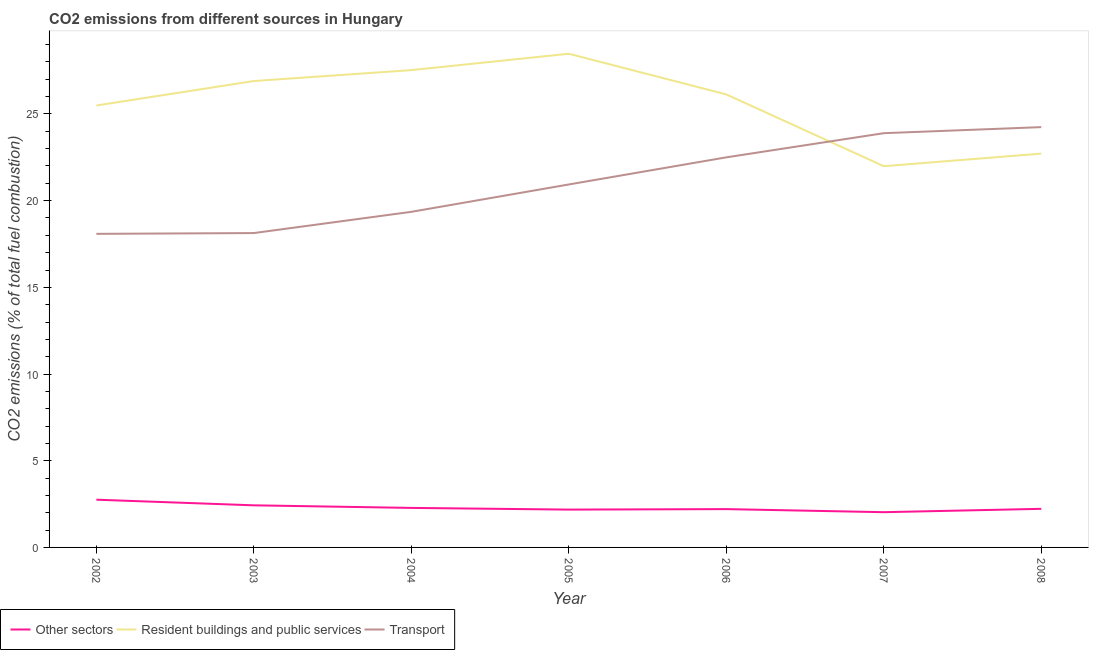What is the percentage of co2 emissions from transport in 2008?
Offer a very short reply. 24.24. Across all years, what is the maximum percentage of co2 emissions from resident buildings and public services?
Keep it short and to the point. 28.47. Across all years, what is the minimum percentage of co2 emissions from other sectors?
Your response must be concise. 2.03. In which year was the percentage of co2 emissions from transport maximum?
Your response must be concise. 2008. In which year was the percentage of co2 emissions from transport minimum?
Your response must be concise. 2002. What is the total percentage of co2 emissions from other sectors in the graph?
Give a very brief answer. 16.11. What is the difference between the percentage of co2 emissions from resident buildings and public services in 2003 and that in 2005?
Your answer should be compact. -1.57. What is the difference between the percentage of co2 emissions from other sectors in 2008 and the percentage of co2 emissions from transport in 2004?
Offer a terse response. -17.13. What is the average percentage of co2 emissions from transport per year?
Offer a terse response. 21.02. In the year 2007, what is the difference between the percentage of co2 emissions from other sectors and percentage of co2 emissions from resident buildings and public services?
Keep it short and to the point. -19.96. In how many years, is the percentage of co2 emissions from other sectors greater than 26 %?
Your answer should be compact. 0. What is the ratio of the percentage of co2 emissions from other sectors in 2002 to that in 2008?
Offer a very short reply. 1.24. What is the difference between the highest and the second highest percentage of co2 emissions from other sectors?
Ensure brevity in your answer.  0.33. What is the difference between the highest and the lowest percentage of co2 emissions from resident buildings and public services?
Ensure brevity in your answer.  6.48. In how many years, is the percentage of co2 emissions from other sectors greater than the average percentage of co2 emissions from other sectors taken over all years?
Your response must be concise. 2. Is the percentage of co2 emissions from resident buildings and public services strictly greater than the percentage of co2 emissions from other sectors over the years?
Keep it short and to the point. Yes. How many lines are there?
Give a very brief answer. 3. How many years are there in the graph?
Your answer should be very brief. 7. Does the graph contain any zero values?
Your answer should be compact. No. Does the graph contain grids?
Provide a succinct answer. No. How are the legend labels stacked?
Provide a succinct answer. Horizontal. What is the title of the graph?
Give a very brief answer. CO2 emissions from different sources in Hungary. What is the label or title of the X-axis?
Give a very brief answer. Year. What is the label or title of the Y-axis?
Offer a terse response. CO2 emissions (% of total fuel combustion). What is the CO2 emissions (% of total fuel combustion) of Other sectors in 2002?
Your response must be concise. 2.75. What is the CO2 emissions (% of total fuel combustion) in Resident buildings and public services in 2002?
Make the answer very short. 25.49. What is the CO2 emissions (% of total fuel combustion) in Transport in 2002?
Your answer should be very brief. 18.09. What is the CO2 emissions (% of total fuel combustion) of Other sectors in 2003?
Provide a succinct answer. 2.43. What is the CO2 emissions (% of total fuel combustion) in Resident buildings and public services in 2003?
Offer a very short reply. 26.9. What is the CO2 emissions (% of total fuel combustion) in Transport in 2003?
Offer a terse response. 18.13. What is the CO2 emissions (% of total fuel combustion) in Other sectors in 2004?
Ensure brevity in your answer.  2.28. What is the CO2 emissions (% of total fuel combustion) in Resident buildings and public services in 2004?
Keep it short and to the point. 27.53. What is the CO2 emissions (% of total fuel combustion) in Transport in 2004?
Your response must be concise. 19.36. What is the CO2 emissions (% of total fuel combustion) of Other sectors in 2005?
Provide a succinct answer. 2.18. What is the CO2 emissions (% of total fuel combustion) of Resident buildings and public services in 2005?
Your answer should be compact. 28.47. What is the CO2 emissions (% of total fuel combustion) of Transport in 2005?
Your answer should be very brief. 20.93. What is the CO2 emissions (% of total fuel combustion) of Other sectors in 2006?
Keep it short and to the point. 2.21. What is the CO2 emissions (% of total fuel combustion) in Resident buildings and public services in 2006?
Keep it short and to the point. 26.13. What is the CO2 emissions (% of total fuel combustion) of Transport in 2006?
Your answer should be very brief. 22.5. What is the CO2 emissions (% of total fuel combustion) in Other sectors in 2007?
Provide a succinct answer. 2.03. What is the CO2 emissions (% of total fuel combustion) of Resident buildings and public services in 2007?
Keep it short and to the point. 21.99. What is the CO2 emissions (% of total fuel combustion) of Transport in 2007?
Keep it short and to the point. 23.89. What is the CO2 emissions (% of total fuel combustion) in Other sectors in 2008?
Provide a succinct answer. 2.23. What is the CO2 emissions (% of total fuel combustion) in Resident buildings and public services in 2008?
Provide a short and direct response. 22.71. What is the CO2 emissions (% of total fuel combustion) of Transport in 2008?
Offer a terse response. 24.24. Across all years, what is the maximum CO2 emissions (% of total fuel combustion) of Other sectors?
Provide a succinct answer. 2.75. Across all years, what is the maximum CO2 emissions (% of total fuel combustion) in Resident buildings and public services?
Provide a short and direct response. 28.47. Across all years, what is the maximum CO2 emissions (% of total fuel combustion) of Transport?
Your answer should be very brief. 24.24. Across all years, what is the minimum CO2 emissions (% of total fuel combustion) of Other sectors?
Provide a succinct answer. 2.03. Across all years, what is the minimum CO2 emissions (% of total fuel combustion) of Resident buildings and public services?
Make the answer very short. 21.99. Across all years, what is the minimum CO2 emissions (% of total fuel combustion) of Transport?
Your response must be concise. 18.09. What is the total CO2 emissions (% of total fuel combustion) in Other sectors in the graph?
Offer a terse response. 16.11. What is the total CO2 emissions (% of total fuel combustion) in Resident buildings and public services in the graph?
Ensure brevity in your answer.  179.22. What is the total CO2 emissions (% of total fuel combustion) of Transport in the graph?
Ensure brevity in your answer.  147.13. What is the difference between the CO2 emissions (% of total fuel combustion) in Other sectors in 2002 and that in 2003?
Ensure brevity in your answer.  0.33. What is the difference between the CO2 emissions (% of total fuel combustion) of Resident buildings and public services in 2002 and that in 2003?
Your answer should be very brief. -1.41. What is the difference between the CO2 emissions (% of total fuel combustion) of Transport in 2002 and that in 2003?
Keep it short and to the point. -0.05. What is the difference between the CO2 emissions (% of total fuel combustion) in Other sectors in 2002 and that in 2004?
Your response must be concise. 0.47. What is the difference between the CO2 emissions (% of total fuel combustion) of Resident buildings and public services in 2002 and that in 2004?
Offer a very short reply. -2.04. What is the difference between the CO2 emissions (% of total fuel combustion) of Transport in 2002 and that in 2004?
Provide a succinct answer. -1.27. What is the difference between the CO2 emissions (% of total fuel combustion) in Other sectors in 2002 and that in 2005?
Your answer should be very brief. 0.57. What is the difference between the CO2 emissions (% of total fuel combustion) in Resident buildings and public services in 2002 and that in 2005?
Offer a terse response. -2.98. What is the difference between the CO2 emissions (% of total fuel combustion) in Transport in 2002 and that in 2005?
Give a very brief answer. -2.85. What is the difference between the CO2 emissions (% of total fuel combustion) of Other sectors in 2002 and that in 2006?
Provide a short and direct response. 0.54. What is the difference between the CO2 emissions (% of total fuel combustion) in Resident buildings and public services in 2002 and that in 2006?
Your response must be concise. -0.64. What is the difference between the CO2 emissions (% of total fuel combustion) of Transport in 2002 and that in 2006?
Give a very brief answer. -4.41. What is the difference between the CO2 emissions (% of total fuel combustion) in Other sectors in 2002 and that in 2007?
Your response must be concise. 0.72. What is the difference between the CO2 emissions (% of total fuel combustion) of Resident buildings and public services in 2002 and that in 2007?
Ensure brevity in your answer.  3.5. What is the difference between the CO2 emissions (% of total fuel combustion) of Transport in 2002 and that in 2007?
Your answer should be very brief. -5.81. What is the difference between the CO2 emissions (% of total fuel combustion) of Other sectors in 2002 and that in 2008?
Your response must be concise. 0.53. What is the difference between the CO2 emissions (% of total fuel combustion) in Resident buildings and public services in 2002 and that in 2008?
Provide a short and direct response. 2.77. What is the difference between the CO2 emissions (% of total fuel combustion) in Transport in 2002 and that in 2008?
Make the answer very short. -6.16. What is the difference between the CO2 emissions (% of total fuel combustion) in Other sectors in 2003 and that in 2004?
Provide a short and direct response. 0.15. What is the difference between the CO2 emissions (% of total fuel combustion) in Resident buildings and public services in 2003 and that in 2004?
Keep it short and to the point. -0.63. What is the difference between the CO2 emissions (% of total fuel combustion) in Transport in 2003 and that in 2004?
Your response must be concise. -1.22. What is the difference between the CO2 emissions (% of total fuel combustion) of Other sectors in 2003 and that in 2005?
Provide a succinct answer. 0.25. What is the difference between the CO2 emissions (% of total fuel combustion) of Resident buildings and public services in 2003 and that in 2005?
Offer a very short reply. -1.57. What is the difference between the CO2 emissions (% of total fuel combustion) in Transport in 2003 and that in 2005?
Ensure brevity in your answer.  -2.8. What is the difference between the CO2 emissions (% of total fuel combustion) of Other sectors in 2003 and that in 2006?
Keep it short and to the point. 0.22. What is the difference between the CO2 emissions (% of total fuel combustion) in Resident buildings and public services in 2003 and that in 2006?
Your answer should be compact. 0.77. What is the difference between the CO2 emissions (% of total fuel combustion) of Transport in 2003 and that in 2006?
Your response must be concise. -4.37. What is the difference between the CO2 emissions (% of total fuel combustion) in Other sectors in 2003 and that in 2007?
Give a very brief answer. 0.4. What is the difference between the CO2 emissions (% of total fuel combustion) in Resident buildings and public services in 2003 and that in 2007?
Offer a very short reply. 4.91. What is the difference between the CO2 emissions (% of total fuel combustion) of Transport in 2003 and that in 2007?
Your answer should be compact. -5.76. What is the difference between the CO2 emissions (% of total fuel combustion) in Other sectors in 2003 and that in 2008?
Your answer should be compact. 0.2. What is the difference between the CO2 emissions (% of total fuel combustion) in Resident buildings and public services in 2003 and that in 2008?
Offer a terse response. 4.19. What is the difference between the CO2 emissions (% of total fuel combustion) of Transport in 2003 and that in 2008?
Your response must be concise. -6.11. What is the difference between the CO2 emissions (% of total fuel combustion) in Other sectors in 2004 and that in 2005?
Offer a terse response. 0.1. What is the difference between the CO2 emissions (% of total fuel combustion) in Resident buildings and public services in 2004 and that in 2005?
Provide a short and direct response. -0.94. What is the difference between the CO2 emissions (% of total fuel combustion) in Transport in 2004 and that in 2005?
Offer a terse response. -1.58. What is the difference between the CO2 emissions (% of total fuel combustion) of Other sectors in 2004 and that in 2006?
Keep it short and to the point. 0.07. What is the difference between the CO2 emissions (% of total fuel combustion) in Resident buildings and public services in 2004 and that in 2006?
Your response must be concise. 1.4. What is the difference between the CO2 emissions (% of total fuel combustion) in Transport in 2004 and that in 2006?
Provide a succinct answer. -3.14. What is the difference between the CO2 emissions (% of total fuel combustion) in Other sectors in 2004 and that in 2007?
Give a very brief answer. 0.25. What is the difference between the CO2 emissions (% of total fuel combustion) of Resident buildings and public services in 2004 and that in 2007?
Provide a succinct answer. 5.54. What is the difference between the CO2 emissions (% of total fuel combustion) of Transport in 2004 and that in 2007?
Keep it short and to the point. -4.54. What is the difference between the CO2 emissions (% of total fuel combustion) of Other sectors in 2004 and that in 2008?
Keep it short and to the point. 0.05. What is the difference between the CO2 emissions (% of total fuel combustion) of Resident buildings and public services in 2004 and that in 2008?
Ensure brevity in your answer.  4.82. What is the difference between the CO2 emissions (% of total fuel combustion) in Transport in 2004 and that in 2008?
Offer a terse response. -4.89. What is the difference between the CO2 emissions (% of total fuel combustion) in Other sectors in 2005 and that in 2006?
Make the answer very short. -0.03. What is the difference between the CO2 emissions (% of total fuel combustion) in Resident buildings and public services in 2005 and that in 2006?
Offer a very short reply. 2.35. What is the difference between the CO2 emissions (% of total fuel combustion) of Transport in 2005 and that in 2006?
Provide a short and direct response. -1.56. What is the difference between the CO2 emissions (% of total fuel combustion) of Other sectors in 2005 and that in 2007?
Offer a very short reply. 0.15. What is the difference between the CO2 emissions (% of total fuel combustion) in Resident buildings and public services in 2005 and that in 2007?
Offer a terse response. 6.48. What is the difference between the CO2 emissions (% of total fuel combustion) of Transport in 2005 and that in 2007?
Your answer should be very brief. -2.96. What is the difference between the CO2 emissions (% of total fuel combustion) of Other sectors in 2005 and that in 2008?
Ensure brevity in your answer.  -0.04. What is the difference between the CO2 emissions (% of total fuel combustion) of Resident buildings and public services in 2005 and that in 2008?
Offer a terse response. 5.76. What is the difference between the CO2 emissions (% of total fuel combustion) in Transport in 2005 and that in 2008?
Provide a short and direct response. -3.31. What is the difference between the CO2 emissions (% of total fuel combustion) in Other sectors in 2006 and that in 2007?
Offer a very short reply. 0.18. What is the difference between the CO2 emissions (% of total fuel combustion) of Resident buildings and public services in 2006 and that in 2007?
Make the answer very short. 4.14. What is the difference between the CO2 emissions (% of total fuel combustion) of Transport in 2006 and that in 2007?
Your response must be concise. -1.39. What is the difference between the CO2 emissions (% of total fuel combustion) of Other sectors in 2006 and that in 2008?
Offer a terse response. -0.02. What is the difference between the CO2 emissions (% of total fuel combustion) of Resident buildings and public services in 2006 and that in 2008?
Ensure brevity in your answer.  3.41. What is the difference between the CO2 emissions (% of total fuel combustion) in Transport in 2006 and that in 2008?
Provide a short and direct response. -1.74. What is the difference between the CO2 emissions (% of total fuel combustion) of Other sectors in 2007 and that in 2008?
Provide a short and direct response. -0.19. What is the difference between the CO2 emissions (% of total fuel combustion) in Resident buildings and public services in 2007 and that in 2008?
Give a very brief answer. -0.72. What is the difference between the CO2 emissions (% of total fuel combustion) of Transport in 2007 and that in 2008?
Provide a short and direct response. -0.35. What is the difference between the CO2 emissions (% of total fuel combustion) of Other sectors in 2002 and the CO2 emissions (% of total fuel combustion) of Resident buildings and public services in 2003?
Your answer should be compact. -24.15. What is the difference between the CO2 emissions (% of total fuel combustion) of Other sectors in 2002 and the CO2 emissions (% of total fuel combustion) of Transport in 2003?
Offer a very short reply. -15.38. What is the difference between the CO2 emissions (% of total fuel combustion) of Resident buildings and public services in 2002 and the CO2 emissions (% of total fuel combustion) of Transport in 2003?
Provide a short and direct response. 7.36. What is the difference between the CO2 emissions (% of total fuel combustion) of Other sectors in 2002 and the CO2 emissions (% of total fuel combustion) of Resident buildings and public services in 2004?
Offer a terse response. -24.78. What is the difference between the CO2 emissions (% of total fuel combustion) in Other sectors in 2002 and the CO2 emissions (% of total fuel combustion) in Transport in 2004?
Give a very brief answer. -16.6. What is the difference between the CO2 emissions (% of total fuel combustion) of Resident buildings and public services in 2002 and the CO2 emissions (% of total fuel combustion) of Transport in 2004?
Make the answer very short. 6.13. What is the difference between the CO2 emissions (% of total fuel combustion) in Other sectors in 2002 and the CO2 emissions (% of total fuel combustion) in Resident buildings and public services in 2005?
Your answer should be compact. -25.72. What is the difference between the CO2 emissions (% of total fuel combustion) of Other sectors in 2002 and the CO2 emissions (% of total fuel combustion) of Transport in 2005?
Make the answer very short. -18.18. What is the difference between the CO2 emissions (% of total fuel combustion) of Resident buildings and public services in 2002 and the CO2 emissions (% of total fuel combustion) of Transport in 2005?
Your answer should be compact. 4.55. What is the difference between the CO2 emissions (% of total fuel combustion) in Other sectors in 2002 and the CO2 emissions (% of total fuel combustion) in Resident buildings and public services in 2006?
Ensure brevity in your answer.  -23.37. What is the difference between the CO2 emissions (% of total fuel combustion) in Other sectors in 2002 and the CO2 emissions (% of total fuel combustion) in Transport in 2006?
Keep it short and to the point. -19.74. What is the difference between the CO2 emissions (% of total fuel combustion) in Resident buildings and public services in 2002 and the CO2 emissions (% of total fuel combustion) in Transport in 2006?
Give a very brief answer. 2.99. What is the difference between the CO2 emissions (% of total fuel combustion) of Other sectors in 2002 and the CO2 emissions (% of total fuel combustion) of Resident buildings and public services in 2007?
Your answer should be very brief. -19.24. What is the difference between the CO2 emissions (% of total fuel combustion) in Other sectors in 2002 and the CO2 emissions (% of total fuel combustion) in Transport in 2007?
Make the answer very short. -21.14. What is the difference between the CO2 emissions (% of total fuel combustion) of Resident buildings and public services in 2002 and the CO2 emissions (% of total fuel combustion) of Transport in 2007?
Keep it short and to the point. 1.6. What is the difference between the CO2 emissions (% of total fuel combustion) in Other sectors in 2002 and the CO2 emissions (% of total fuel combustion) in Resident buildings and public services in 2008?
Keep it short and to the point. -19.96. What is the difference between the CO2 emissions (% of total fuel combustion) of Other sectors in 2002 and the CO2 emissions (% of total fuel combustion) of Transport in 2008?
Your answer should be compact. -21.49. What is the difference between the CO2 emissions (% of total fuel combustion) in Resident buildings and public services in 2002 and the CO2 emissions (% of total fuel combustion) in Transport in 2008?
Your answer should be very brief. 1.25. What is the difference between the CO2 emissions (% of total fuel combustion) in Other sectors in 2003 and the CO2 emissions (% of total fuel combustion) in Resident buildings and public services in 2004?
Ensure brevity in your answer.  -25.1. What is the difference between the CO2 emissions (% of total fuel combustion) of Other sectors in 2003 and the CO2 emissions (% of total fuel combustion) of Transport in 2004?
Give a very brief answer. -16.93. What is the difference between the CO2 emissions (% of total fuel combustion) in Resident buildings and public services in 2003 and the CO2 emissions (% of total fuel combustion) in Transport in 2004?
Give a very brief answer. 7.54. What is the difference between the CO2 emissions (% of total fuel combustion) of Other sectors in 2003 and the CO2 emissions (% of total fuel combustion) of Resident buildings and public services in 2005?
Ensure brevity in your answer.  -26.04. What is the difference between the CO2 emissions (% of total fuel combustion) of Other sectors in 2003 and the CO2 emissions (% of total fuel combustion) of Transport in 2005?
Keep it short and to the point. -18.51. What is the difference between the CO2 emissions (% of total fuel combustion) of Resident buildings and public services in 2003 and the CO2 emissions (% of total fuel combustion) of Transport in 2005?
Provide a succinct answer. 5.97. What is the difference between the CO2 emissions (% of total fuel combustion) in Other sectors in 2003 and the CO2 emissions (% of total fuel combustion) in Resident buildings and public services in 2006?
Your answer should be very brief. -23.7. What is the difference between the CO2 emissions (% of total fuel combustion) in Other sectors in 2003 and the CO2 emissions (% of total fuel combustion) in Transport in 2006?
Provide a succinct answer. -20.07. What is the difference between the CO2 emissions (% of total fuel combustion) of Resident buildings and public services in 2003 and the CO2 emissions (% of total fuel combustion) of Transport in 2006?
Make the answer very short. 4.4. What is the difference between the CO2 emissions (% of total fuel combustion) in Other sectors in 2003 and the CO2 emissions (% of total fuel combustion) in Resident buildings and public services in 2007?
Provide a short and direct response. -19.56. What is the difference between the CO2 emissions (% of total fuel combustion) in Other sectors in 2003 and the CO2 emissions (% of total fuel combustion) in Transport in 2007?
Provide a succinct answer. -21.46. What is the difference between the CO2 emissions (% of total fuel combustion) in Resident buildings and public services in 2003 and the CO2 emissions (% of total fuel combustion) in Transport in 2007?
Offer a terse response. 3.01. What is the difference between the CO2 emissions (% of total fuel combustion) of Other sectors in 2003 and the CO2 emissions (% of total fuel combustion) of Resident buildings and public services in 2008?
Make the answer very short. -20.28. What is the difference between the CO2 emissions (% of total fuel combustion) of Other sectors in 2003 and the CO2 emissions (% of total fuel combustion) of Transport in 2008?
Your answer should be compact. -21.81. What is the difference between the CO2 emissions (% of total fuel combustion) in Resident buildings and public services in 2003 and the CO2 emissions (% of total fuel combustion) in Transport in 2008?
Provide a short and direct response. 2.66. What is the difference between the CO2 emissions (% of total fuel combustion) of Other sectors in 2004 and the CO2 emissions (% of total fuel combustion) of Resident buildings and public services in 2005?
Give a very brief answer. -26.19. What is the difference between the CO2 emissions (% of total fuel combustion) in Other sectors in 2004 and the CO2 emissions (% of total fuel combustion) in Transport in 2005?
Your answer should be compact. -18.65. What is the difference between the CO2 emissions (% of total fuel combustion) in Resident buildings and public services in 2004 and the CO2 emissions (% of total fuel combustion) in Transport in 2005?
Ensure brevity in your answer.  6.6. What is the difference between the CO2 emissions (% of total fuel combustion) of Other sectors in 2004 and the CO2 emissions (% of total fuel combustion) of Resident buildings and public services in 2006?
Make the answer very short. -23.85. What is the difference between the CO2 emissions (% of total fuel combustion) in Other sectors in 2004 and the CO2 emissions (% of total fuel combustion) in Transport in 2006?
Provide a succinct answer. -20.22. What is the difference between the CO2 emissions (% of total fuel combustion) of Resident buildings and public services in 2004 and the CO2 emissions (% of total fuel combustion) of Transport in 2006?
Your answer should be compact. 5.03. What is the difference between the CO2 emissions (% of total fuel combustion) of Other sectors in 2004 and the CO2 emissions (% of total fuel combustion) of Resident buildings and public services in 2007?
Offer a terse response. -19.71. What is the difference between the CO2 emissions (% of total fuel combustion) of Other sectors in 2004 and the CO2 emissions (% of total fuel combustion) of Transport in 2007?
Your response must be concise. -21.61. What is the difference between the CO2 emissions (% of total fuel combustion) in Resident buildings and public services in 2004 and the CO2 emissions (% of total fuel combustion) in Transport in 2007?
Your answer should be compact. 3.64. What is the difference between the CO2 emissions (% of total fuel combustion) of Other sectors in 2004 and the CO2 emissions (% of total fuel combustion) of Resident buildings and public services in 2008?
Your response must be concise. -20.43. What is the difference between the CO2 emissions (% of total fuel combustion) in Other sectors in 2004 and the CO2 emissions (% of total fuel combustion) in Transport in 2008?
Your response must be concise. -21.96. What is the difference between the CO2 emissions (% of total fuel combustion) in Resident buildings and public services in 2004 and the CO2 emissions (% of total fuel combustion) in Transport in 2008?
Provide a short and direct response. 3.29. What is the difference between the CO2 emissions (% of total fuel combustion) in Other sectors in 2005 and the CO2 emissions (% of total fuel combustion) in Resident buildings and public services in 2006?
Your response must be concise. -23.95. What is the difference between the CO2 emissions (% of total fuel combustion) in Other sectors in 2005 and the CO2 emissions (% of total fuel combustion) in Transport in 2006?
Offer a very short reply. -20.32. What is the difference between the CO2 emissions (% of total fuel combustion) in Resident buildings and public services in 2005 and the CO2 emissions (% of total fuel combustion) in Transport in 2006?
Offer a terse response. 5.97. What is the difference between the CO2 emissions (% of total fuel combustion) of Other sectors in 2005 and the CO2 emissions (% of total fuel combustion) of Resident buildings and public services in 2007?
Offer a terse response. -19.81. What is the difference between the CO2 emissions (% of total fuel combustion) of Other sectors in 2005 and the CO2 emissions (% of total fuel combustion) of Transport in 2007?
Ensure brevity in your answer.  -21.71. What is the difference between the CO2 emissions (% of total fuel combustion) in Resident buildings and public services in 2005 and the CO2 emissions (% of total fuel combustion) in Transport in 2007?
Offer a very short reply. 4.58. What is the difference between the CO2 emissions (% of total fuel combustion) of Other sectors in 2005 and the CO2 emissions (% of total fuel combustion) of Resident buildings and public services in 2008?
Your answer should be compact. -20.53. What is the difference between the CO2 emissions (% of total fuel combustion) in Other sectors in 2005 and the CO2 emissions (% of total fuel combustion) in Transport in 2008?
Offer a terse response. -22.06. What is the difference between the CO2 emissions (% of total fuel combustion) in Resident buildings and public services in 2005 and the CO2 emissions (% of total fuel combustion) in Transport in 2008?
Keep it short and to the point. 4.23. What is the difference between the CO2 emissions (% of total fuel combustion) in Other sectors in 2006 and the CO2 emissions (% of total fuel combustion) in Resident buildings and public services in 2007?
Your response must be concise. -19.78. What is the difference between the CO2 emissions (% of total fuel combustion) in Other sectors in 2006 and the CO2 emissions (% of total fuel combustion) in Transport in 2007?
Your response must be concise. -21.68. What is the difference between the CO2 emissions (% of total fuel combustion) in Resident buildings and public services in 2006 and the CO2 emissions (% of total fuel combustion) in Transport in 2007?
Ensure brevity in your answer.  2.24. What is the difference between the CO2 emissions (% of total fuel combustion) of Other sectors in 2006 and the CO2 emissions (% of total fuel combustion) of Resident buildings and public services in 2008?
Your answer should be compact. -20.5. What is the difference between the CO2 emissions (% of total fuel combustion) in Other sectors in 2006 and the CO2 emissions (% of total fuel combustion) in Transport in 2008?
Offer a terse response. -22.03. What is the difference between the CO2 emissions (% of total fuel combustion) of Resident buildings and public services in 2006 and the CO2 emissions (% of total fuel combustion) of Transport in 2008?
Your response must be concise. 1.89. What is the difference between the CO2 emissions (% of total fuel combustion) of Other sectors in 2007 and the CO2 emissions (% of total fuel combustion) of Resident buildings and public services in 2008?
Provide a succinct answer. -20.68. What is the difference between the CO2 emissions (% of total fuel combustion) in Other sectors in 2007 and the CO2 emissions (% of total fuel combustion) in Transport in 2008?
Offer a terse response. -22.21. What is the difference between the CO2 emissions (% of total fuel combustion) of Resident buildings and public services in 2007 and the CO2 emissions (% of total fuel combustion) of Transport in 2008?
Ensure brevity in your answer.  -2.25. What is the average CO2 emissions (% of total fuel combustion) of Other sectors per year?
Offer a very short reply. 2.3. What is the average CO2 emissions (% of total fuel combustion) in Resident buildings and public services per year?
Provide a short and direct response. 25.6. What is the average CO2 emissions (% of total fuel combustion) in Transport per year?
Make the answer very short. 21.02. In the year 2002, what is the difference between the CO2 emissions (% of total fuel combustion) in Other sectors and CO2 emissions (% of total fuel combustion) in Resident buildings and public services?
Provide a short and direct response. -22.73. In the year 2002, what is the difference between the CO2 emissions (% of total fuel combustion) of Other sectors and CO2 emissions (% of total fuel combustion) of Transport?
Offer a terse response. -15.33. In the year 2002, what is the difference between the CO2 emissions (% of total fuel combustion) of Resident buildings and public services and CO2 emissions (% of total fuel combustion) of Transport?
Give a very brief answer. 7.4. In the year 2003, what is the difference between the CO2 emissions (% of total fuel combustion) of Other sectors and CO2 emissions (% of total fuel combustion) of Resident buildings and public services?
Offer a terse response. -24.47. In the year 2003, what is the difference between the CO2 emissions (% of total fuel combustion) of Other sectors and CO2 emissions (% of total fuel combustion) of Transport?
Provide a succinct answer. -15.7. In the year 2003, what is the difference between the CO2 emissions (% of total fuel combustion) of Resident buildings and public services and CO2 emissions (% of total fuel combustion) of Transport?
Provide a short and direct response. 8.77. In the year 2004, what is the difference between the CO2 emissions (% of total fuel combustion) in Other sectors and CO2 emissions (% of total fuel combustion) in Resident buildings and public services?
Ensure brevity in your answer.  -25.25. In the year 2004, what is the difference between the CO2 emissions (% of total fuel combustion) of Other sectors and CO2 emissions (% of total fuel combustion) of Transport?
Your answer should be very brief. -17.08. In the year 2004, what is the difference between the CO2 emissions (% of total fuel combustion) in Resident buildings and public services and CO2 emissions (% of total fuel combustion) in Transport?
Offer a very short reply. 8.17. In the year 2005, what is the difference between the CO2 emissions (% of total fuel combustion) in Other sectors and CO2 emissions (% of total fuel combustion) in Resident buildings and public services?
Your response must be concise. -26.29. In the year 2005, what is the difference between the CO2 emissions (% of total fuel combustion) of Other sectors and CO2 emissions (% of total fuel combustion) of Transport?
Make the answer very short. -18.75. In the year 2005, what is the difference between the CO2 emissions (% of total fuel combustion) of Resident buildings and public services and CO2 emissions (% of total fuel combustion) of Transport?
Your response must be concise. 7.54. In the year 2006, what is the difference between the CO2 emissions (% of total fuel combustion) of Other sectors and CO2 emissions (% of total fuel combustion) of Resident buildings and public services?
Ensure brevity in your answer.  -23.92. In the year 2006, what is the difference between the CO2 emissions (% of total fuel combustion) in Other sectors and CO2 emissions (% of total fuel combustion) in Transport?
Offer a terse response. -20.29. In the year 2006, what is the difference between the CO2 emissions (% of total fuel combustion) in Resident buildings and public services and CO2 emissions (% of total fuel combustion) in Transport?
Offer a terse response. 3.63. In the year 2007, what is the difference between the CO2 emissions (% of total fuel combustion) in Other sectors and CO2 emissions (% of total fuel combustion) in Resident buildings and public services?
Provide a succinct answer. -19.96. In the year 2007, what is the difference between the CO2 emissions (% of total fuel combustion) in Other sectors and CO2 emissions (% of total fuel combustion) in Transport?
Your answer should be very brief. -21.86. In the year 2007, what is the difference between the CO2 emissions (% of total fuel combustion) of Resident buildings and public services and CO2 emissions (% of total fuel combustion) of Transport?
Your answer should be very brief. -1.9. In the year 2008, what is the difference between the CO2 emissions (% of total fuel combustion) of Other sectors and CO2 emissions (% of total fuel combustion) of Resident buildings and public services?
Offer a very short reply. -20.49. In the year 2008, what is the difference between the CO2 emissions (% of total fuel combustion) of Other sectors and CO2 emissions (% of total fuel combustion) of Transport?
Offer a very short reply. -22.01. In the year 2008, what is the difference between the CO2 emissions (% of total fuel combustion) in Resident buildings and public services and CO2 emissions (% of total fuel combustion) in Transport?
Provide a short and direct response. -1.53. What is the ratio of the CO2 emissions (% of total fuel combustion) in Other sectors in 2002 to that in 2003?
Keep it short and to the point. 1.13. What is the ratio of the CO2 emissions (% of total fuel combustion) in Resident buildings and public services in 2002 to that in 2003?
Your answer should be compact. 0.95. What is the ratio of the CO2 emissions (% of total fuel combustion) in Transport in 2002 to that in 2003?
Provide a succinct answer. 1. What is the ratio of the CO2 emissions (% of total fuel combustion) of Other sectors in 2002 to that in 2004?
Ensure brevity in your answer.  1.21. What is the ratio of the CO2 emissions (% of total fuel combustion) in Resident buildings and public services in 2002 to that in 2004?
Your answer should be compact. 0.93. What is the ratio of the CO2 emissions (% of total fuel combustion) in Transport in 2002 to that in 2004?
Keep it short and to the point. 0.93. What is the ratio of the CO2 emissions (% of total fuel combustion) of Other sectors in 2002 to that in 2005?
Provide a short and direct response. 1.26. What is the ratio of the CO2 emissions (% of total fuel combustion) in Resident buildings and public services in 2002 to that in 2005?
Keep it short and to the point. 0.9. What is the ratio of the CO2 emissions (% of total fuel combustion) of Transport in 2002 to that in 2005?
Give a very brief answer. 0.86. What is the ratio of the CO2 emissions (% of total fuel combustion) of Other sectors in 2002 to that in 2006?
Your answer should be very brief. 1.25. What is the ratio of the CO2 emissions (% of total fuel combustion) in Resident buildings and public services in 2002 to that in 2006?
Offer a terse response. 0.98. What is the ratio of the CO2 emissions (% of total fuel combustion) of Transport in 2002 to that in 2006?
Offer a terse response. 0.8. What is the ratio of the CO2 emissions (% of total fuel combustion) in Other sectors in 2002 to that in 2007?
Your response must be concise. 1.35. What is the ratio of the CO2 emissions (% of total fuel combustion) in Resident buildings and public services in 2002 to that in 2007?
Offer a very short reply. 1.16. What is the ratio of the CO2 emissions (% of total fuel combustion) of Transport in 2002 to that in 2007?
Offer a terse response. 0.76. What is the ratio of the CO2 emissions (% of total fuel combustion) of Other sectors in 2002 to that in 2008?
Offer a terse response. 1.24. What is the ratio of the CO2 emissions (% of total fuel combustion) of Resident buildings and public services in 2002 to that in 2008?
Keep it short and to the point. 1.12. What is the ratio of the CO2 emissions (% of total fuel combustion) of Transport in 2002 to that in 2008?
Your answer should be compact. 0.75. What is the ratio of the CO2 emissions (% of total fuel combustion) of Other sectors in 2003 to that in 2004?
Provide a short and direct response. 1.07. What is the ratio of the CO2 emissions (% of total fuel combustion) in Resident buildings and public services in 2003 to that in 2004?
Make the answer very short. 0.98. What is the ratio of the CO2 emissions (% of total fuel combustion) in Transport in 2003 to that in 2004?
Provide a succinct answer. 0.94. What is the ratio of the CO2 emissions (% of total fuel combustion) in Other sectors in 2003 to that in 2005?
Ensure brevity in your answer.  1.11. What is the ratio of the CO2 emissions (% of total fuel combustion) in Resident buildings and public services in 2003 to that in 2005?
Keep it short and to the point. 0.94. What is the ratio of the CO2 emissions (% of total fuel combustion) of Transport in 2003 to that in 2005?
Make the answer very short. 0.87. What is the ratio of the CO2 emissions (% of total fuel combustion) in Other sectors in 2003 to that in 2006?
Keep it short and to the point. 1.1. What is the ratio of the CO2 emissions (% of total fuel combustion) in Resident buildings and public services in 2003 to that in 2006?
Your answer should be very brief. 1.03. What is the ratio of the CO2 emissions (% of total fuel combustion) in Transport in 2003 to that in 2006?
Offer a very short reply. 0.81. What is the ratio of the CO2 emissions (% of total fuel combustion) of Other sectors in 2003 to that in 2007?
Offer a very short reply. 1.19. What is the ratio of the CO2 emissions (% of total fuel combustion) of Resident buildings and public services in 2003 to that in 2007?
Make the answer very short. 1.22. What is the ratio of the CO2 emissions (% of total fuel combustion) in Transport in 2003 to that in 2007?
Your response must be concise. 0.76. What is the ratio of the CO2 emissions (% of total fuel combustion) of Other sectors in 2003 to that in 2008?
Offer a terse response. 1.09. What is the ratio of the CO2 emissions (% of total fuel combustion) of Resident buildings and public services in 2003 to that in 2008?
Make the answer very short. 1.18. What is the ratio of the CO2 emissions (% of total fuel combustion) in Transport in 2003 to that in 2008?
Your response must be concise. 0.75. What is the ratio of the CO2 emissions (% of total fuel combustion) in Other sectors in 2004 to that in 2005?
Your answer should be very brief. 1.04. What is the ratio of the CO2 emissions (% of total fuel combustion) in Resident buildings and public services in 2004 to that in 2005?
Provide a succinct answer. 0.97. What is the ratio of the CO2 emissions (% of total fuel combustion) of Transport in 2004 to that in 2005?
Your answer should be compact. 0.92. What is the ratio of the CO2 emissions (% of total fuel combustion) of Other sectors in 2004 to that in 2006?
Offer a terse response. 1.03. What is the ratio of the CO2 emissions (% of total fuel combustion) of Resident buildings and public services in 2004 to that in 2006?
Ensure brevity in your answer.  1.05. What is the ratio of the CO2 emissions (% of total fuel combustion) in Transport in 2004 to that in 2006?
Provide a succinct answer. 0.86. What is the ratio of the CO2 emissions (% of total fuel combustion) in Other sectors in 2004 to that in 2007?
Your answer should be very brief. 1.12. What is the ratio of the CO2 emissions (% of total fuel combustion) of Resident buildings and public services in 2004 to that in 2007?
Provide a short and direct response. 1.25. What is the ratio of the CO2 emissions (% of total fuel combustion) in Transport in 2004 to that in 2007?
Your answer should be very brief. 0.81. What is the ratio of the CO2 emissions (% of total fuel combustion) of Other sectors in 2004 to that in 2008?
Provide a succinct answer. 1.02. What is the ratio of the CO2 emissions (% of total fuel combustion) in Resident buildings and public services in 2004 to that in 2008?
Your response must be concise. 1.21. What is the ratio of the CO2 emissions (% of total fuel combustion) of Transport in 2004 to that in 2008?
Give a very brief answer. 0.8. What is the ratio of the CO2 emissions (% of total fuel combustion) in Other sectors in 2005 to that in 2006?
Keep it short and to the point. 0.99. What is the ratio of the CO2 emissions (% of total fuel combustion) of Resident buildings and public services in 2005 to that in 2006?
Ensure brevity in your answer.  1.09. What is the ratio of the CO2 emissions (% of total fuel combustion) in Transport in 2005 to that in 2006?
Provide a short and direct response. 0.93. What is the ratio of the CO2 emissions (% of total fuel combustion) of Other sectors in 2005 to that in 2007?
Make the answer very short. 1.07. What is the ratio of the CO2 emissions (% of total fuel combustion) in Resident buildings and public services in 2005 to that in 2007?
Your answer should be compact. 1.29. What is the ratio of the CO2 emissions (% of total fuel combustion) in Transport in 2005 to that in 2007?
Give a very brief answer. 0.88. What is the ratio of the CO2 emissions (% of total fuel combustion) of Other sectors in 2005 to that in 2008?
Your response must be concise. 0.98. What is the ratio of the CO2 emissions (% of total fuel combustion) of Resident buildings and public services in 2005 to that in 2008?
Offer a terse response. 1.25. What is the ratio of the CO2 emissions (% of total fuel combustion) in Transport in 2005 to that in 2008?
Keep it short and to the point. 0.86. What is the ratio of the CO2 emissions (% of total fuel combustion) in Other sectors in 2006 to that in 2007?
Keep it short and to the point. 1.09. What is the ratio of the CO2 emissions (% of total fuel combustion) of Resident buildings and public services in 2006 to that in 2007?
Your answer should be compact. 1.19. What is the ratio of the CO2 emissions (% of total fuel combustion) in Transport in 2006 to that in 2007?
Keep it short and to the point. 0.94. What is the ratio of the CO2 emissions (% of total fuel combustion) in Other sectors in 2006 to that in 2008?
Offer a terse response. 0.99. What is the ratio of the CO2 emissions (% of total fuel combustion) of Resident buildings and public services in 2006 to that in 2008?
Your answer should be very brief. 1.15. What is the ratio of the CO2 emissions (% of total fuel combustion) of Transport in 2006 to that in 2008?
Offer a terse response. 0.93. What is the ratio of the CO2 emissions (% of total fuel combustion) in Other sectors in 2007 to that in 2008?
Provide a short and direct response. 0.91. What is the ratio of the CO2 emissions (% of total fuel combustion) of Resident buildings and public services in 2007 to that in 2008?
Your response must be concise. 0.97. What is the ratio of the CO2 emissions (% of total fuel combustion) in Transport in 2007 to that in 2008?
Make the answer very short. 0.99. What is the difference between the highest and the second highest CO2 emissions (% of total fuel combustion) in Other sectors?
Ensure brevity in your answer.  0.33. What is the difference between the highest and the second highest CO2 emissions (% of total fuel combustion) of Resident buildings and public services?
Make the answer very short. 0.94. What is the difference between the highest and the second highest CO2 emissions (% of total fuel combustion) of Transport?
Your answer should be very brief. 0.35. What is the difference between the highest and the lowest CO2 emissions (% of total fuel combustion) of Other sectors?
Give a very brief answer. 0.72. What is the difference between the highest and the lowest CO2 emissions (% of total fuel combustion) of Resident buildings and public services?
Keep it short and to the point. 6.48. What is the difference between the highest and the lowest CO2 emissions (% of total fuel combustion) of Transport?
Your answer should be very brief. 6.16. 